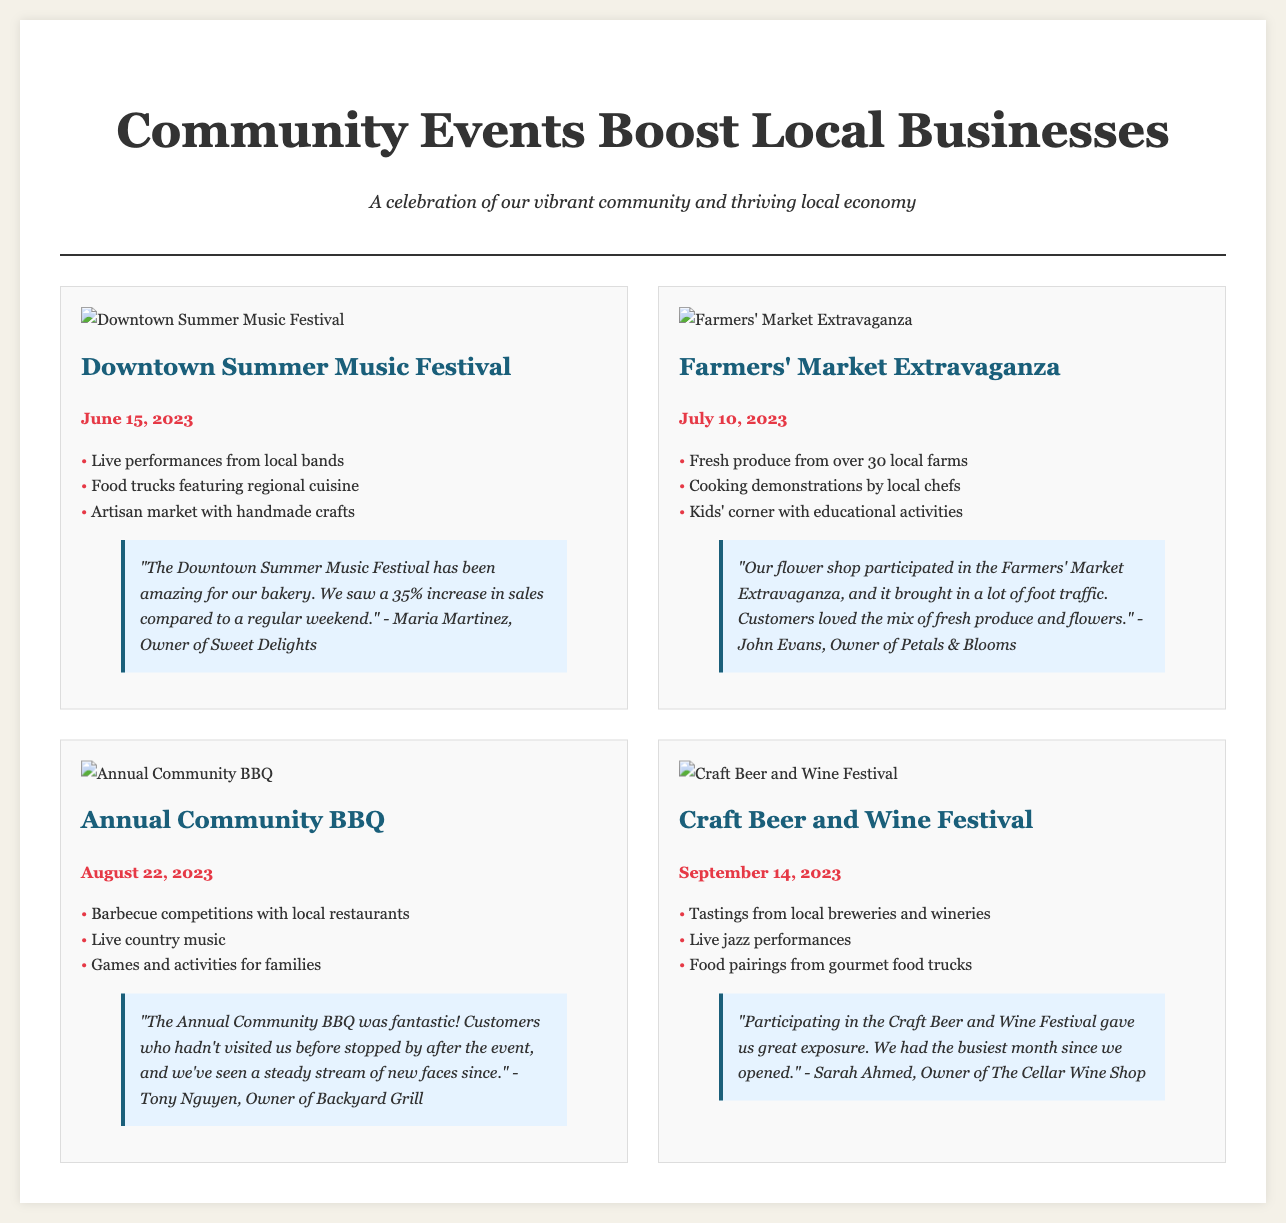What is the title of the main article? The title is prominently displayed at the top of the document and serves as the main focus.
Answer: Community Events Boost Local Businesses How many local farms participated in the Farmers' Market Extravaganza? This information is listed under the event highlights of the Farmers' Market event.
Answer: over 30 What date is the Annual Community BBQ scheduled for? The date is stated prominently under the event title of the Annual Community BBQ.
Answer: August 22, 2023 Who is the owner of Sweet Delights? The owner's name is mentioned in the testimonial related to the Downtown Summer Music Festival.
Answer: Maria Martinez What event features live jazz performances? The event's description provides details about the entertainment offered.
Answer: Craft Beer and Wine Festival How much did sales increase for Maria's bakery during the festival? This specific figure is provided in the testimonial for the Downtown Summer Music Festival.
Answer: 35% Which event had barbecue competitions? This is highlighted as a key activity in the description of the Annual Community BBQ.
Answer: Annual Community BBQ What did Sarah Ahmed say about her store after the Craft Beer and Wine Festival? This is mentioned in the testimonial provided under the event details.
Answer: busiest month since we opened How many events are featured in this newspaper layout? By counting the number of event blocks presented in the document.
Answer: Four 